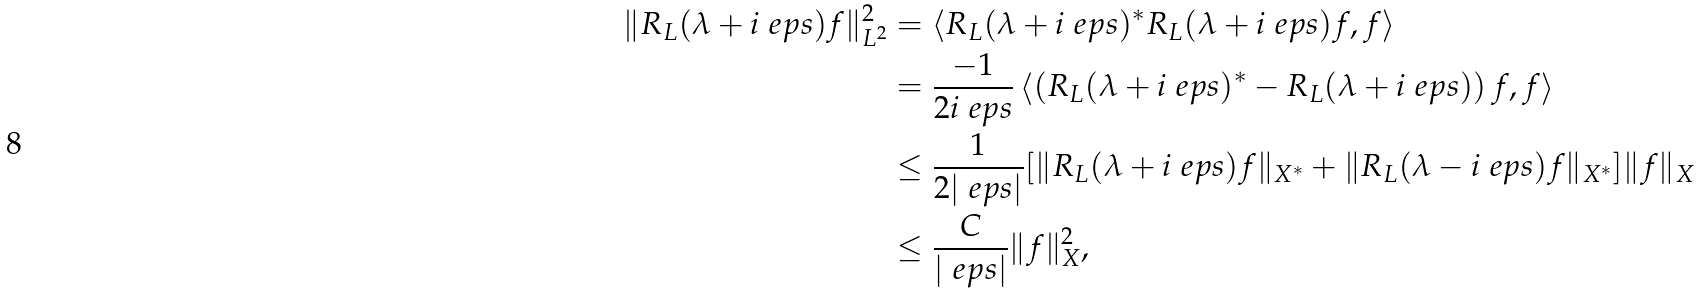<formula> <loc_0><loc_0><loc_500><loc_500>\| R _ { L } ( \lambda + i \ e p s ) f \| _ { L ^ { 2 } } ^ { 2 } & = \langle R _ { L } ( \lambda + i \ e p s ) ^ { * } R _ { L } ( \lambda + i \ e p s ) f , f \rangle \\ & = \frac { - 1 } { 2 i \ e p s } \left \langle \left ( R _ { L } ( \lambda + i \ e p s ) ^ { * } - R _ { L } ( \lambda + i \ e p s ) \right ) f , f \right \rangle \\ & \leq \frac { 1 } { 2 | \ e p s | } [ \| R _ { L } ( \lambda + i \ e p s ) f \| _ { X ^ { * } } + \| R _ { L } ( \lambda - i \ e p s ) f \| _ { X ^ { * } } ] \| f \| _ { X } \\ & \leq \frac { C } { | \ e p s | } \| f \| _ { X } ^ { 2 } ,</formula> 